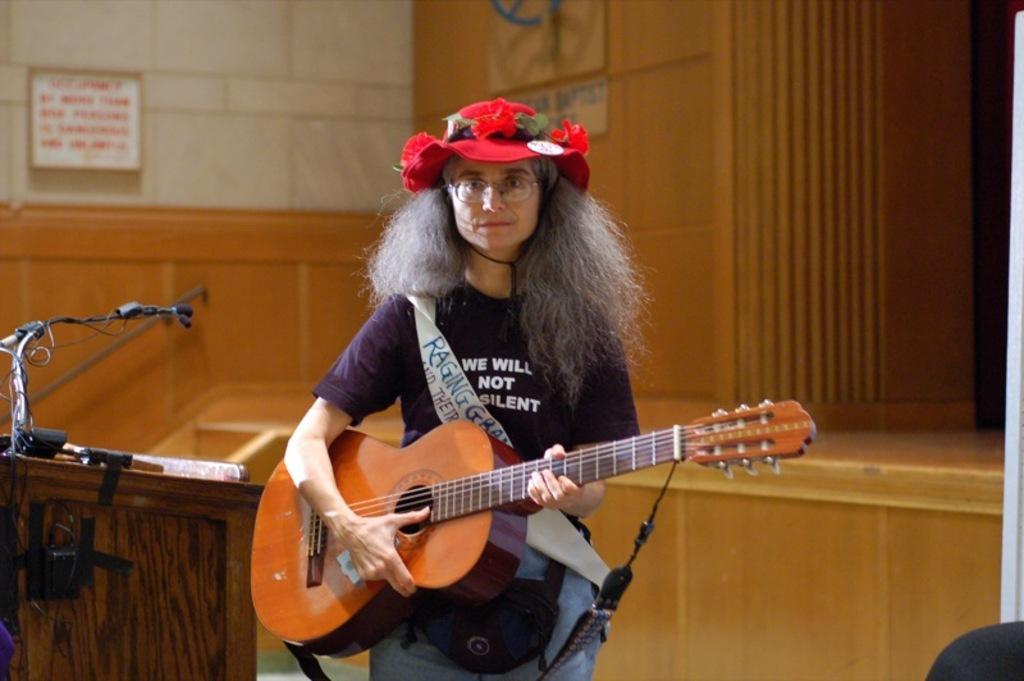Describe this image in one or two sentences. In this picture we see a woman standing and playing a guitar and we see a podium with a microphone 